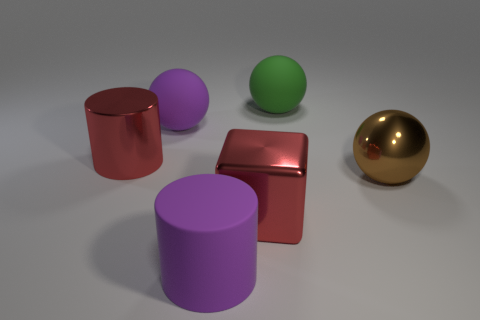How would you describe the textures of the objects in this image? The objects in the image showcase varying textures. The cylinders have a smooth finish, with one featuring a matte texture and the other a metallic sheen. The cube appears to have a slightly reflective surface similar to brushed metal, and the spheres also have a smooth texture, one being matte and the other shiny. 